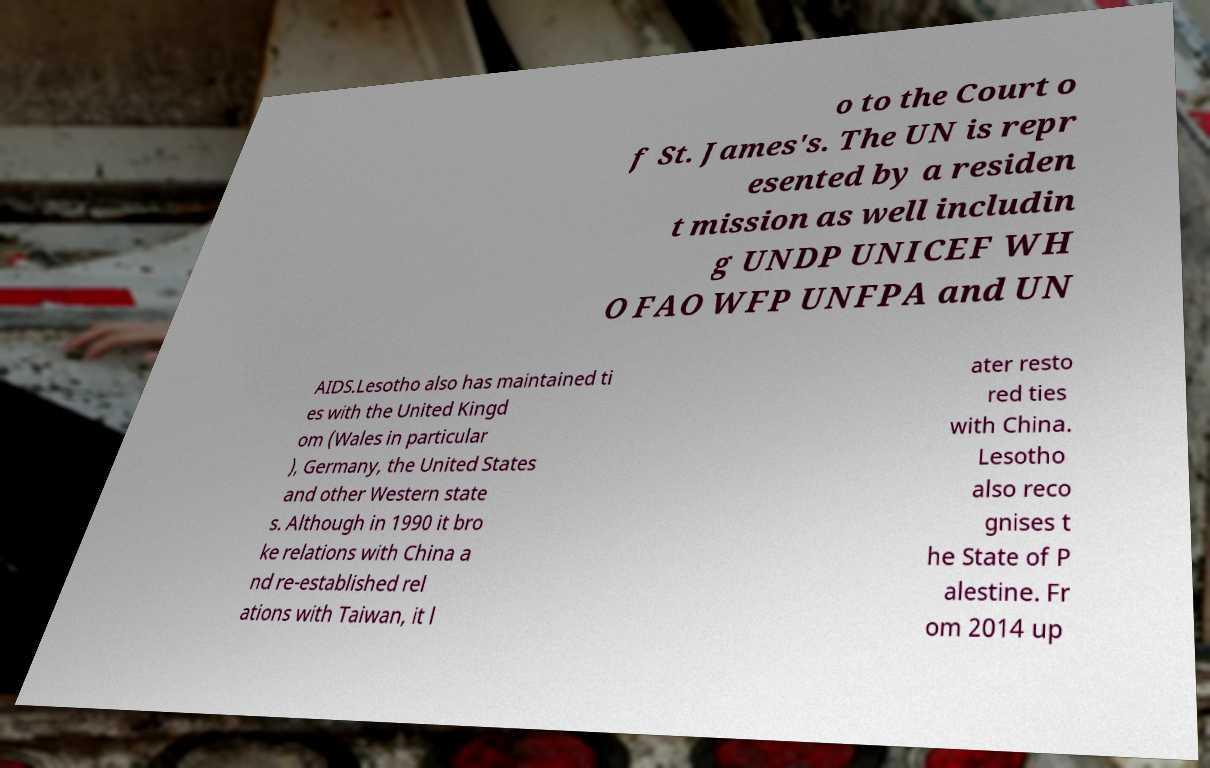What messages or text are displayed in this image? I need them in a readable, typed format. o to the Court o f St. James's. The UN is repr esented by a residen t mission as well includin g UNDP UNICEF WH O FAO WFP UNFPA and UN AIDS.Lesotho also has maintained ti es with the United Kingd om (Wales in particular ), Germany, the United States and other Western state s. Although in 1990 it bro ke relations with China a nd re-established rel ations with Taiwan, it l ater resto red ties with China. Lesotho also reco gnises t he State of P alestine. Fr om 2014 up 